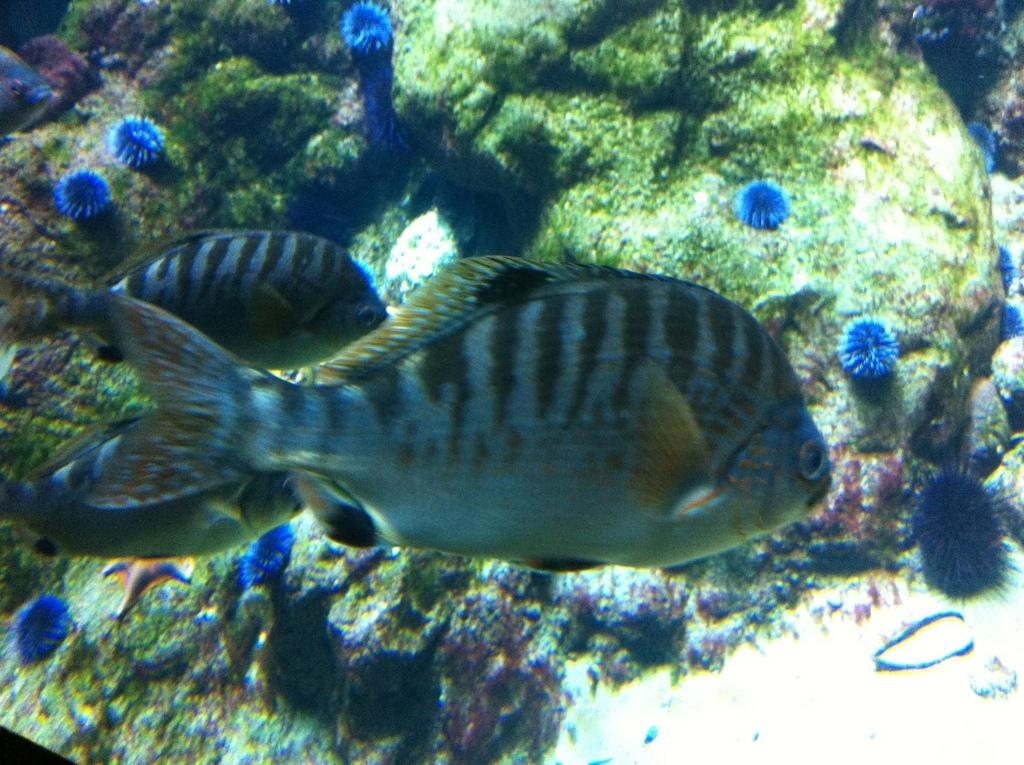What type of animals can be seen in the image? There are fish in the image. What kind of plants are present in the image? There are blue color flowers in the image. What other objects can be seen in the image? There are rocks in the image. Where are all these elements located? All of these elements are in the water. What type of picture is hanging on the wall in the image? There is no mention of a picture hanging on the wall in the image; the focus is on the fish, flowers, and rocks in the water. 